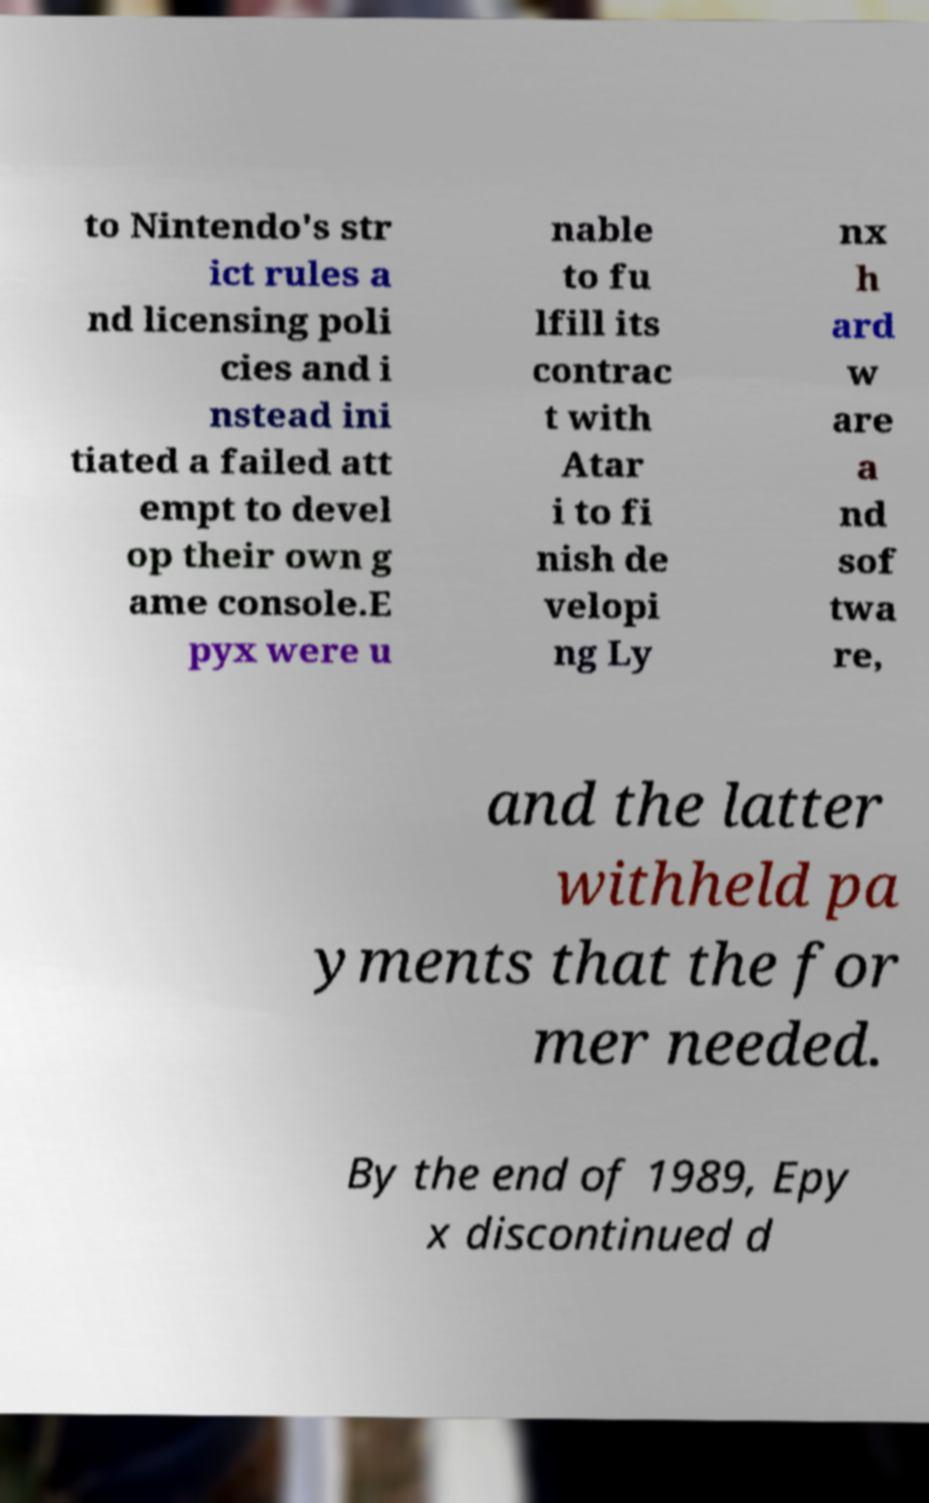Can you accurately transcribe the text from the provided image for me? to Nintendo's str ict rules a nd licensing poli cies and i nstead ini tiated a failed att empt to devel op their own g ame console.E pyx were u nable to fu lfill its contrac t with Atar i to fi nish de velopi ng Ly nx h ard w are a nd sof twa re, and the latter withheld pa yments that the for mer needed. By the end of 1989, Epy x discontinued d 